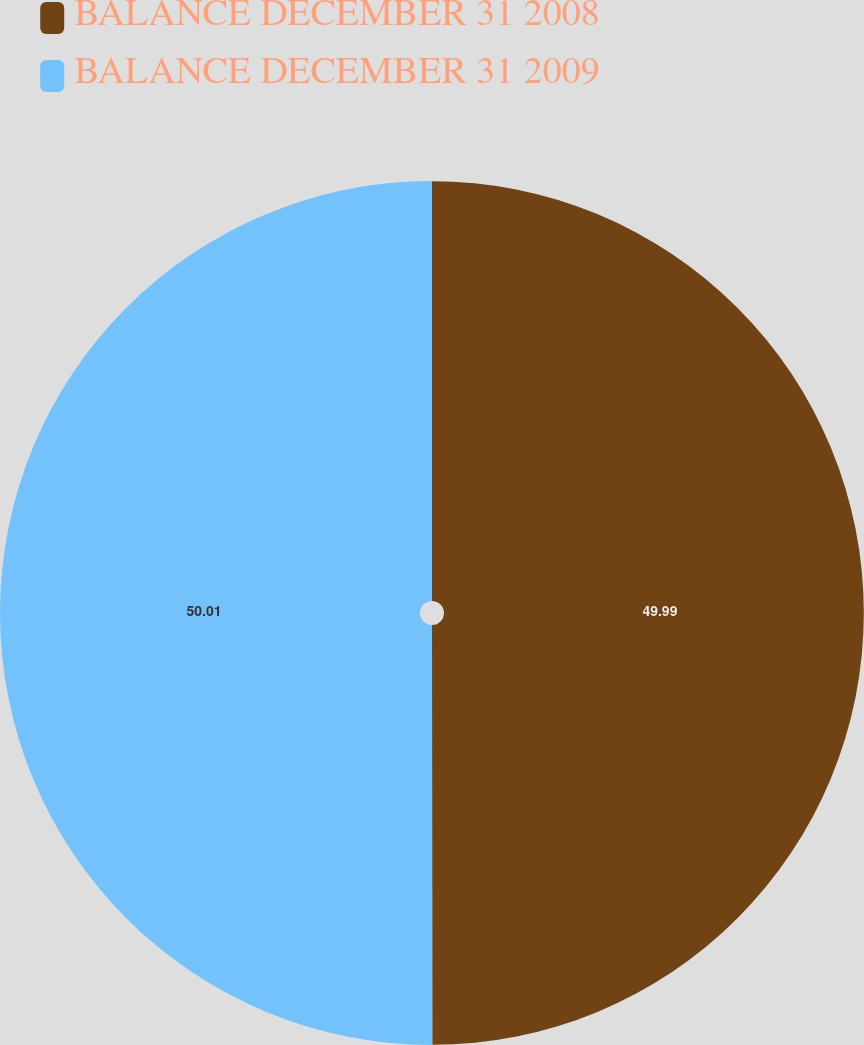Convert chart. <chart><loc_0><loc_0><loc_500><loc_500><pie_chart><fcel>BALANCE DECEMBER 31 2008<fcel>BALANCE DECEMBER 31 2009<nl><fcel>49.99%<fcel>50.01%<nl></chart> 